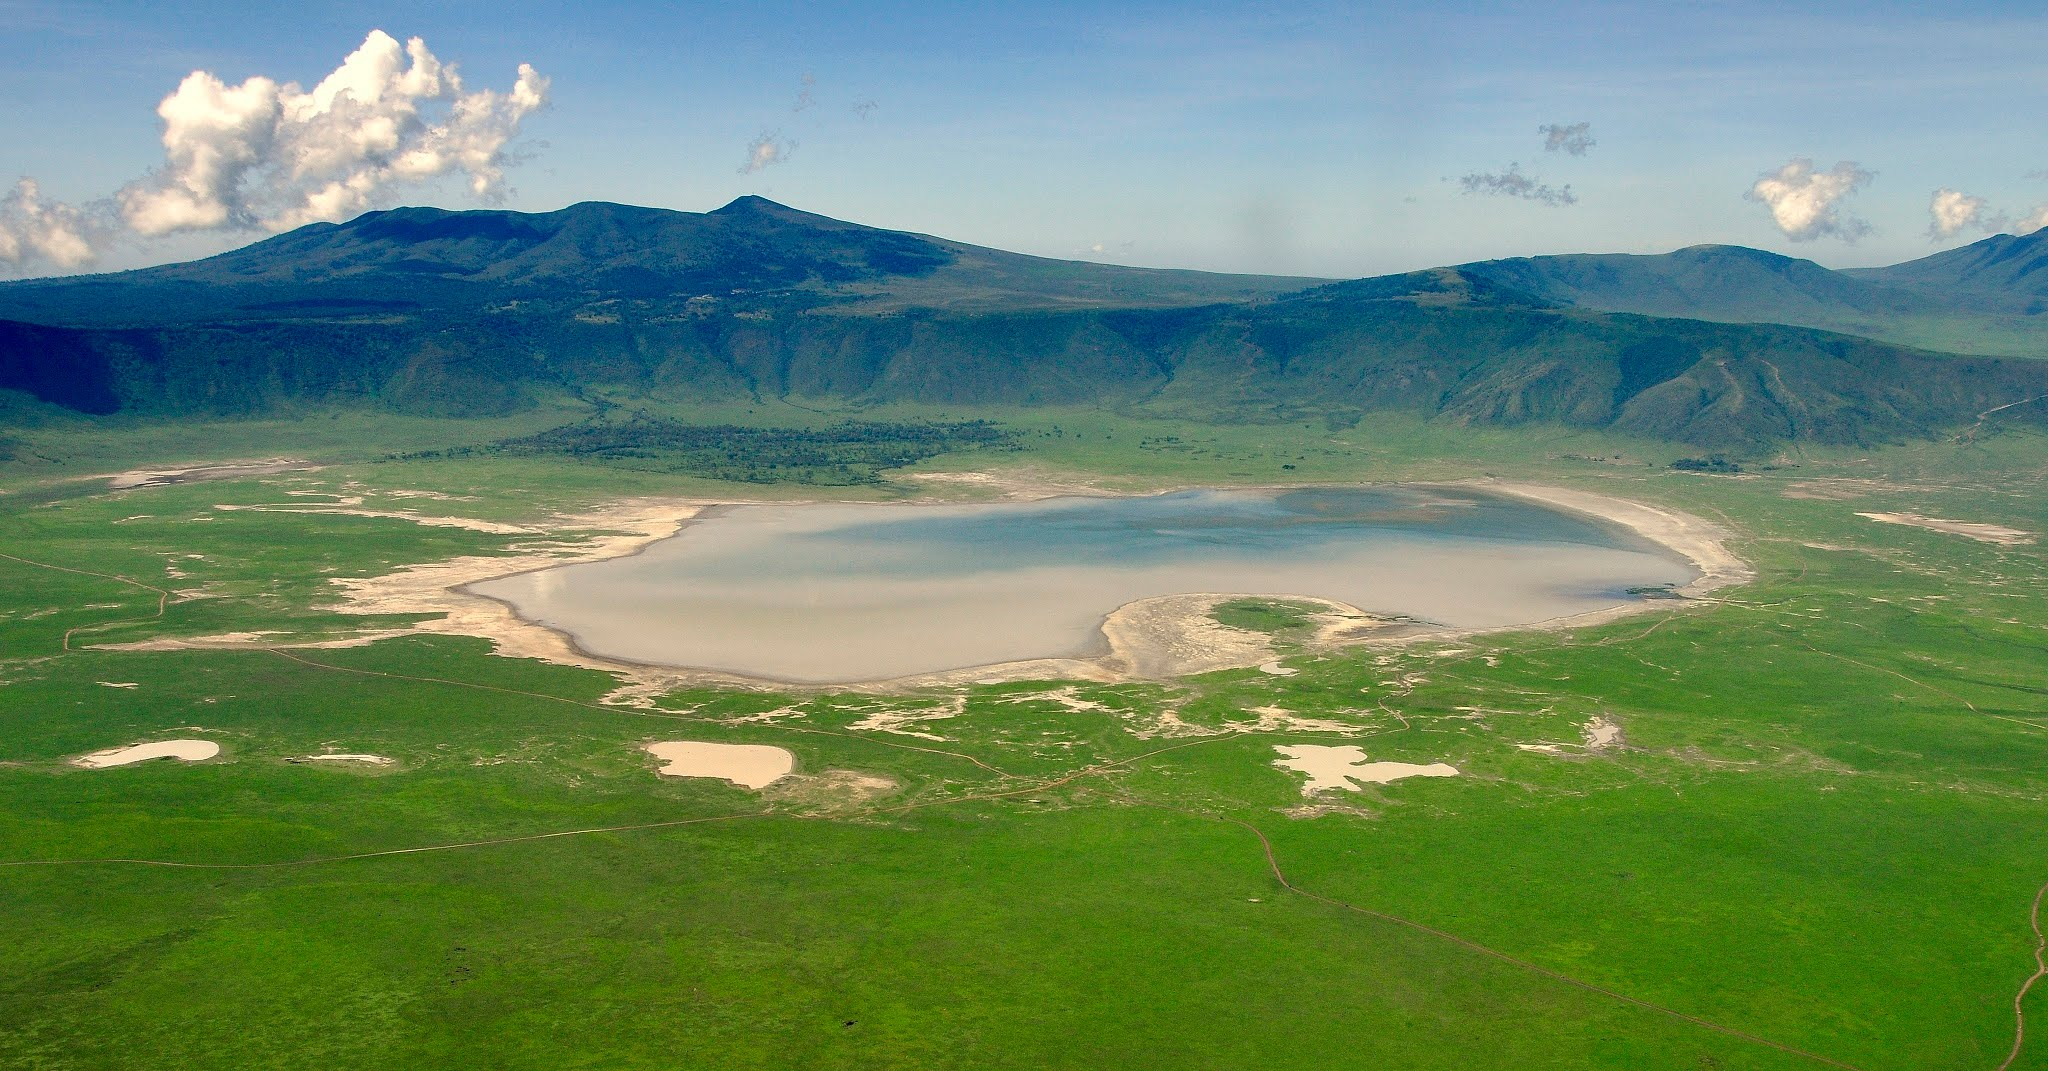How does the unique geography of the Ngorongoro Crater impact its weather patterns? The unique geography of the Ngorongoro Crater significantly impacts its weather patterns. The crater's walls, which are over 2,000 feet high, create a natural barrier that affects wind and weather movement within the caldera. This results in a microclimate that can be markedly different from the surrounding region. The crater floor tends to be cooler and more humid, with frequent early morning mists and, occasionally, rain when moist air is uplifted by the crater walls. The variation in altitude within the crater also contributes to diverse weather experiences across different elevations. Consequently, the crater often experiences milder and more stable weather conditions, which, combined with fertile soils, supports its rich biodiversity. Can you create a fictional story about discovering a hidden treasure within the crater? In the heart of the Ngorongoro Crater, beneath its emerald plains and ancient acacias, a hidden treasure lay undisturbed for centuries. Legends spoke of a Maasai warrior who, in times long past, buried his tribe’s most precious artifacts in a secret grotto to protect them from invaders. Generations later, Jez, an ardent archaeologist, arrived on an expedition to the crater. Guided by old Maasai tales and mysterious carvings, Jez embarked on a quest through the dense forest near the craggy slopes. Her journey was fraught with challenges—navigating through dense undergrowth, evading curious wildlife, and deciphering cryptic symbols. One foggy morning, as sunbeams pierced the mist, Jez stumbled upon a set of ancient steps leading to a concealed cave. Inside, the enchanting glow of gold and gemstones greeted her eyes. The trove held intricately carved masks, ceremonial spears, and ornate jewelry, untouched by time. Jez's discovery not only brought her acclaim but also reignited cultural pride among the Maasai, forging a bridge between the past and present. 